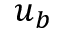Convert formula to latex. <formula><loc_0><loc_0><loc_500><loc_500>u _ { b }</formula> 